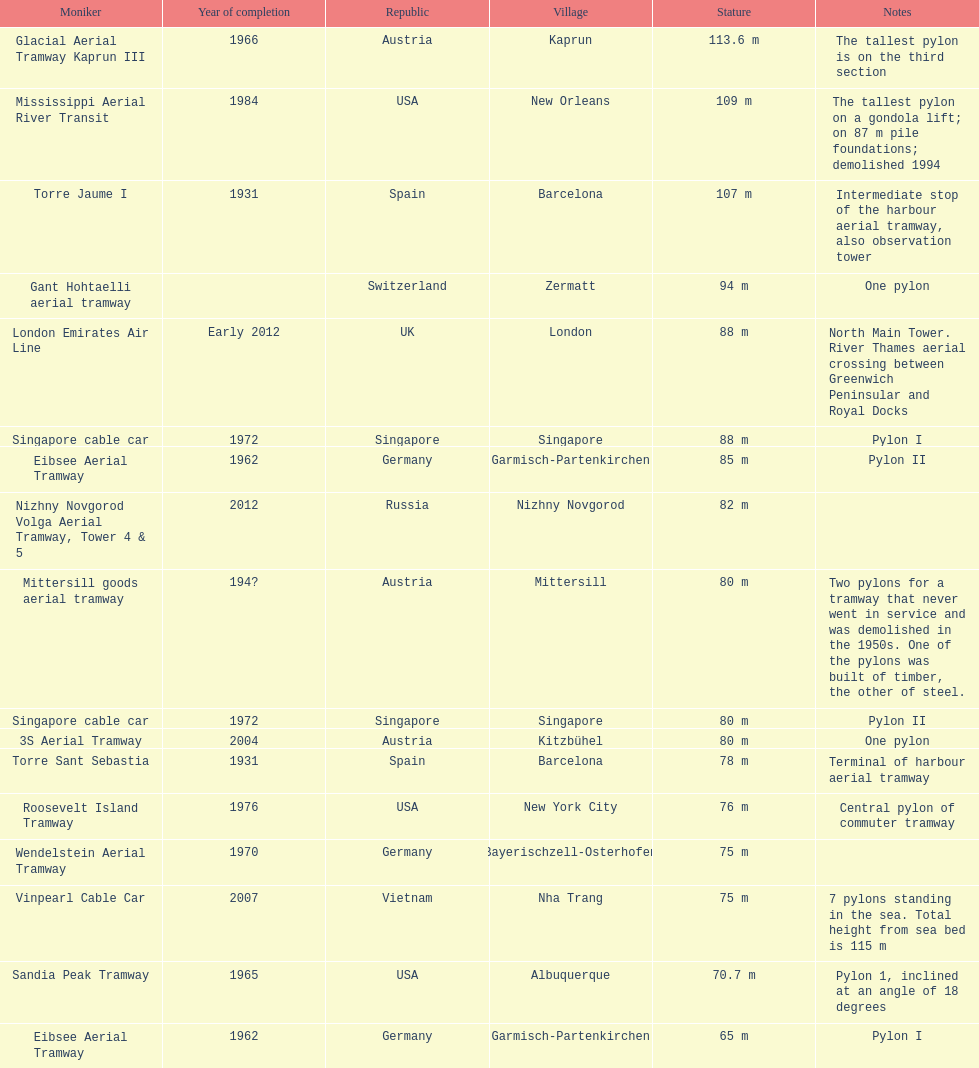How many pylons are at least 80 meters tall? 11. 